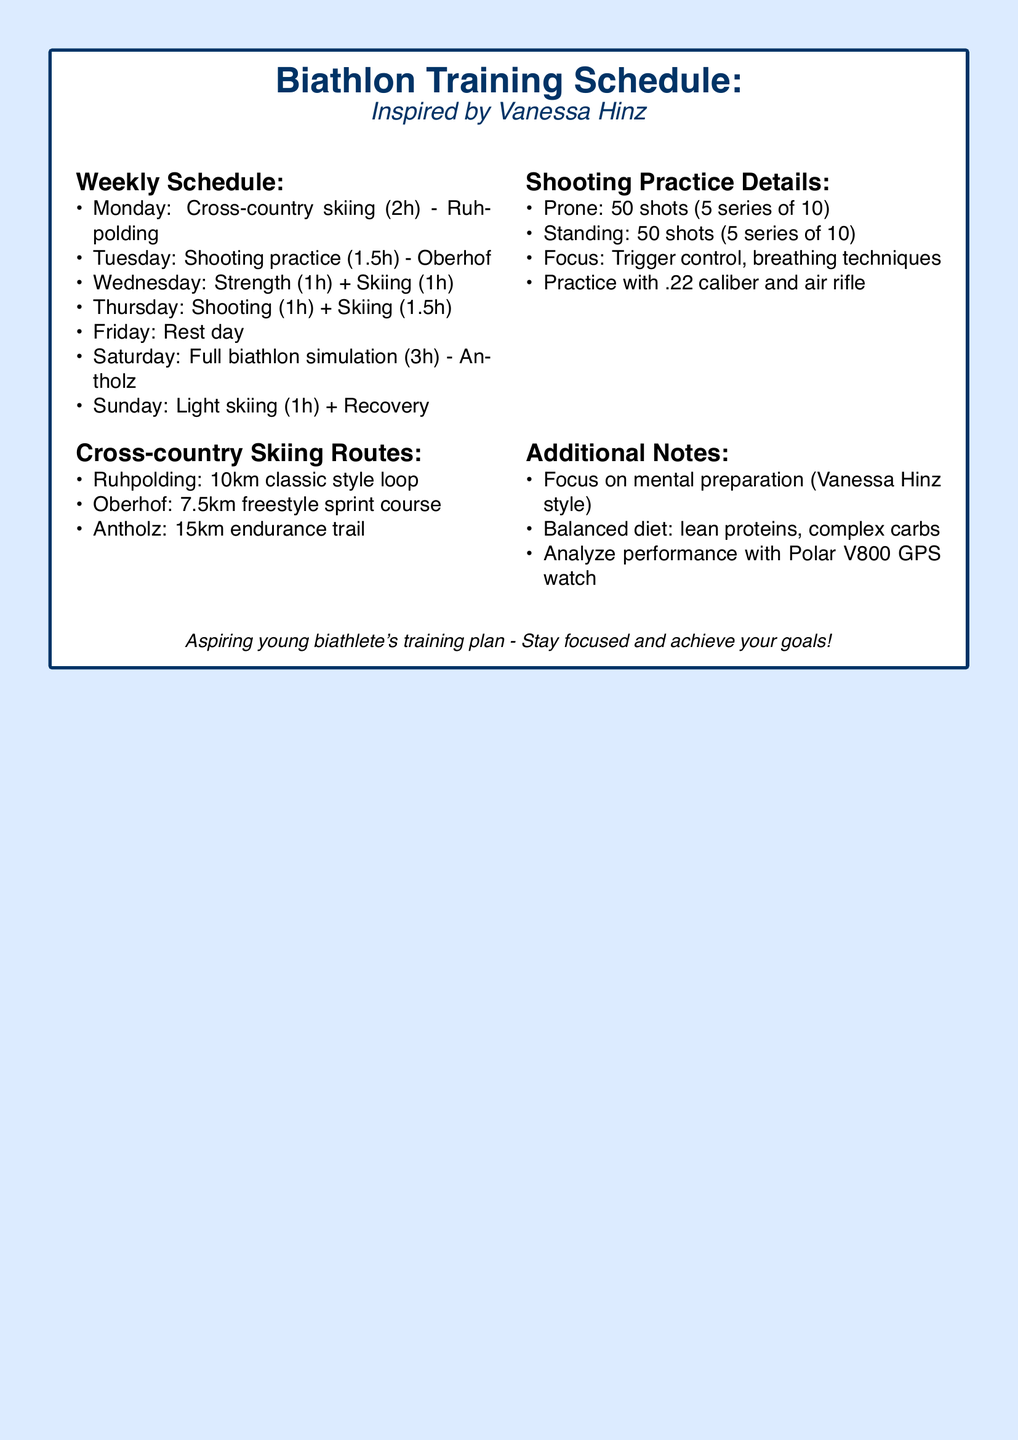What day is the full biathlon simulation scheduled for? The full biathlon simulation is practiced on Saturday according to the training schedule.
Answer: Saturday How long is the shooting practice on Tuesday? The document specifies that shooting practice on Tuesday lasts for 1.5 hours.
Answer: 1.5h What is the total time allocated for cross-country skiing on Monday? The document indicates that Monday's cross-country skiing session lasts for 2 hours.
Answer: 2h Which shooting practice focus is mentioned in the document? The document lists trigger control and breathing techniques as the focuses for shooting practice.
Answer: Trigger control, breathing techniques What is the length of the endurance trail in Antholz? The endurance trail in Antholz measures 15 kilometers as per the skiing routes section.
Answer: 15km How many shots are practiced in the prone position? The document states that 50 shots are practiced in the prone position during shooting practice.
Answer: 50 shots What type of ski style is practiced on the 10km loop in Ruhpolding? The 10km loop in Ruhpolding is practiced in classic style according to the training schedule.
Answer: Classic style On which day is the rest day scheduled? The training schedule specifies that Friday is the designated rest day.
Answer: Friday What equipment is mentioned for shooting practice? The document mentions practicing with .22 caliber and air rifle for shooting practice.
Answer: .22 caliber and air rifle 